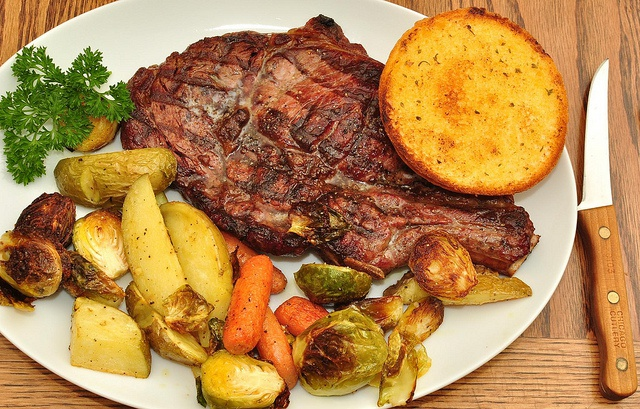Describe the objects in this image and their specific colors. I can see dining table in brown and tan tones, knife in brown, ivory, orange, and maroon tones, carrot in brown, red, and orange tones, carrot in brown, red, and orange tones, and carrot in brown, red, and orange tones in this image. 